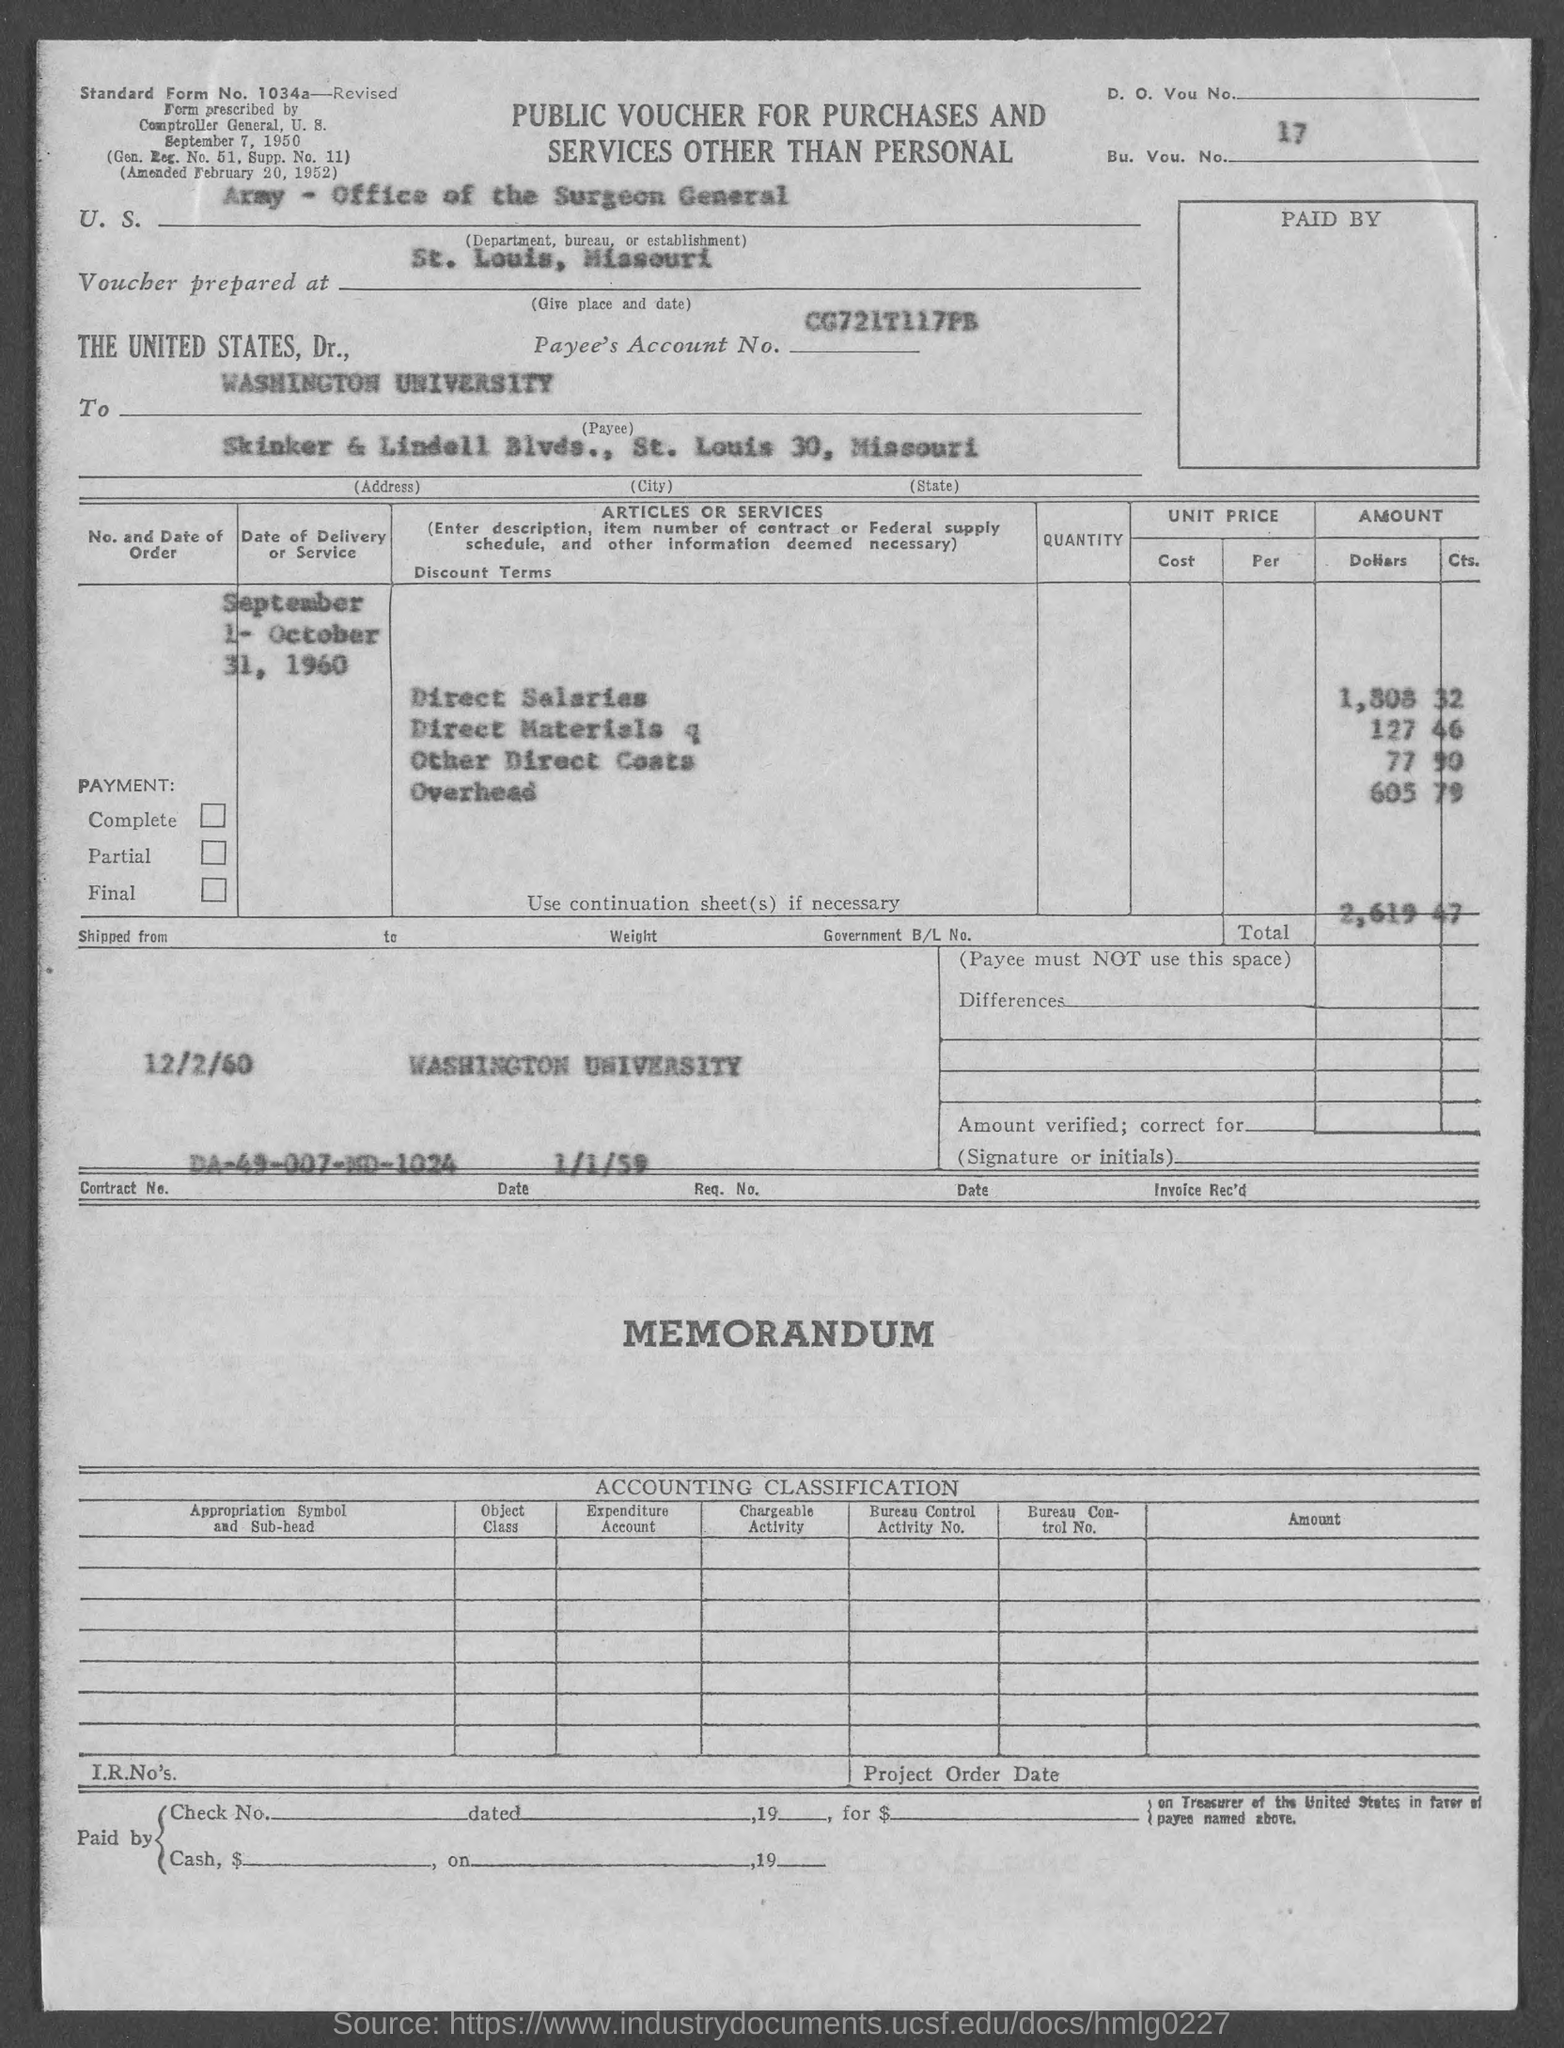Draw attention to some important aspects in this diagram. The total amount of direct salaries is 1,808, with a range of 32. The contract number is DA-49-007-MD-1024. The BU. VOU. number is 17. A voucher is prepared in the state of Missouri. The amount of direct materials is 127 and 46... 